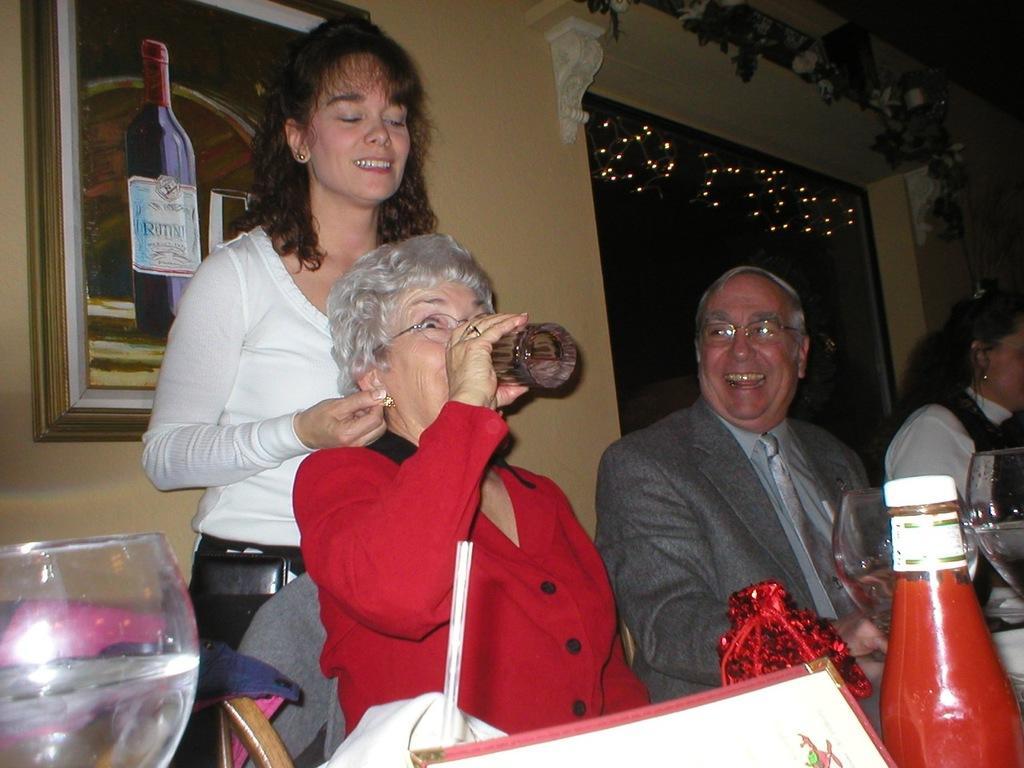Please provide a concise description of this image. A picture on wall. This woman is standing back side of this woman. This woman is drinking a water. This 3 persons are sitting on a chair. On this table there is a bottle, gift wrap and glass. 